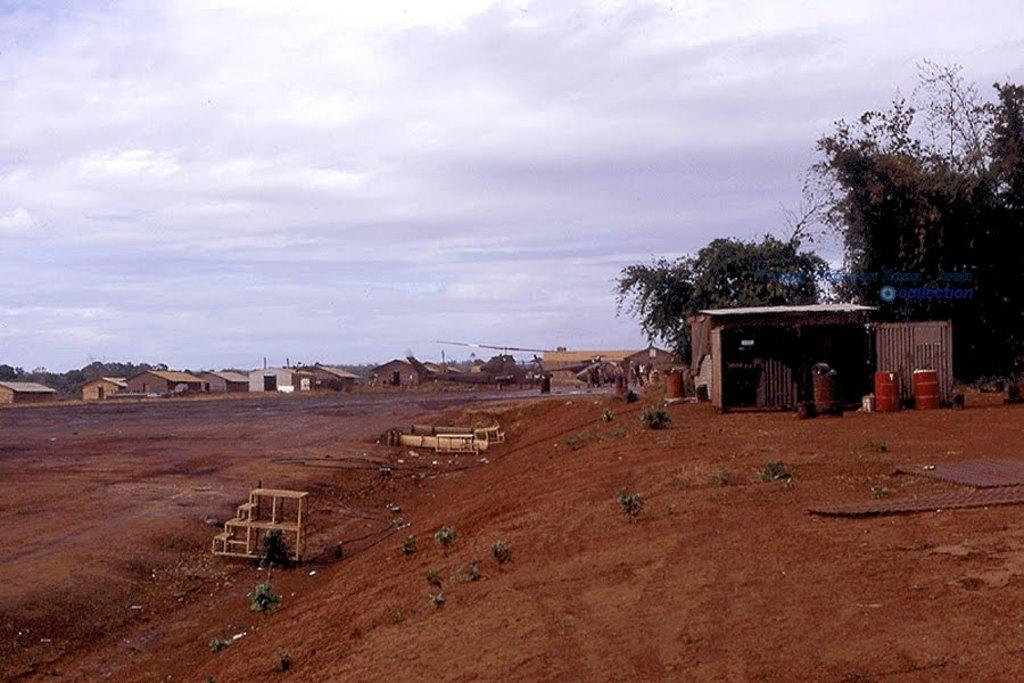What is the texture of the image? The image has a muddy texture. What can be seen in the center of the image? There are houses and trees in the center of the image. What is visible at the top of the image? The sky is visible at the top of the image. What type of horn can be heard in the image? There is no horn present in the image, and therefore no sound can be heard. 